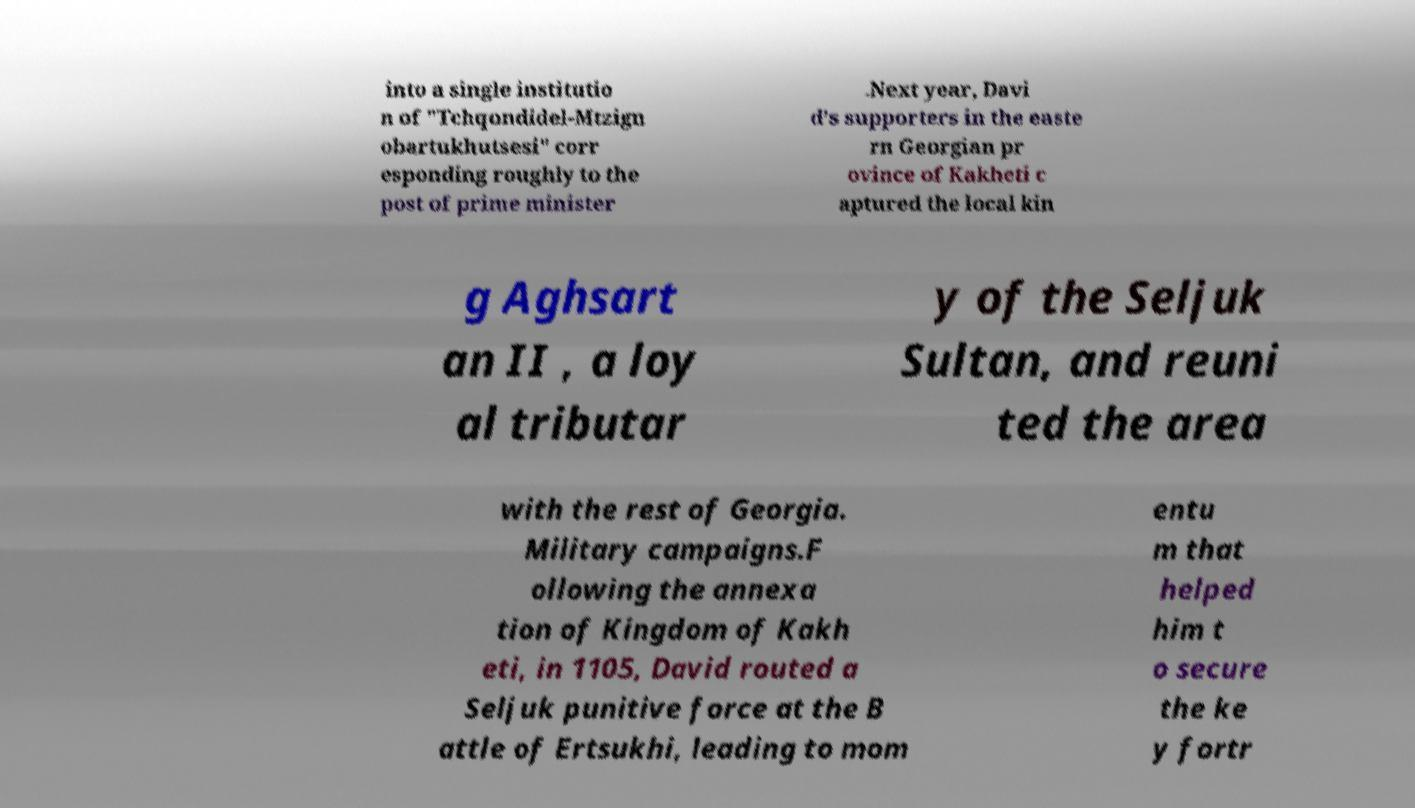Could you extract and type out the text from this image? into a single institutio n of "Tchqondidel-Mtzign obartukhutsesi" corr esponding roughly to the post of prime minister .Next year, Davi d’s supporters in the easte rn Georgian pr ovince of Kakheti c aptured the local kin g Aghsart an II , a loy al tributar y of the Seljuk Sultan, and reuni ted the area with the rest of Georgia. Military campaigns.F ollowing the annexa tion of Kingdom of Kakh eti, in 1105, David routed a Seljuk punitive force at the B attle of Ertsukhi, leading to mom entu m that helped him t o secure the ke y fortr 